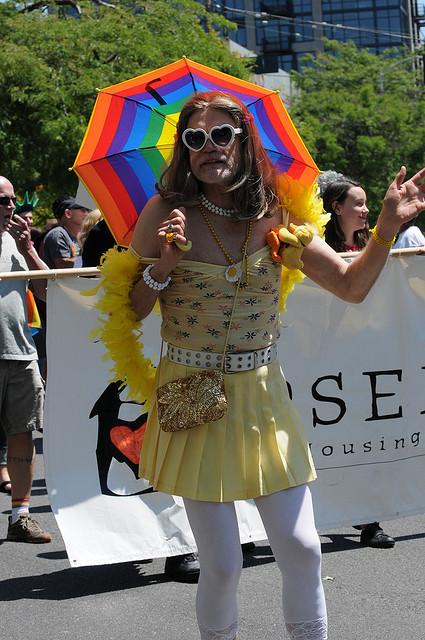What does the man use the umbrella for? shade 